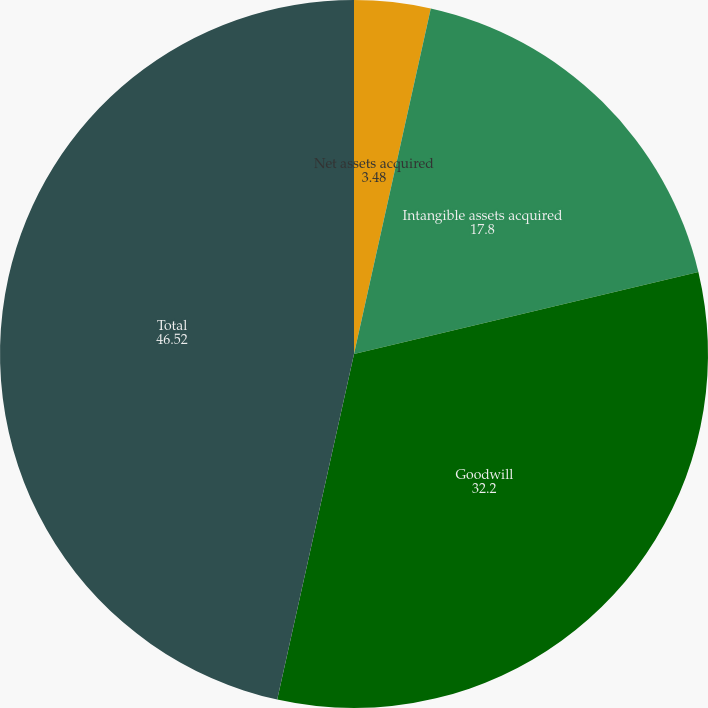Convert chart to OTSL. <chart><loc_0><loc_0><loc_500><loc_500><pie_chart><fcel>Net assets acquired<fcel>Intangible assets acquired<fcel>Goodwill<fcel>Total<nl><fcel>3.48%<fcel>17.8%<fcel>32.2%<fcel>46.52%<nl></chart> 